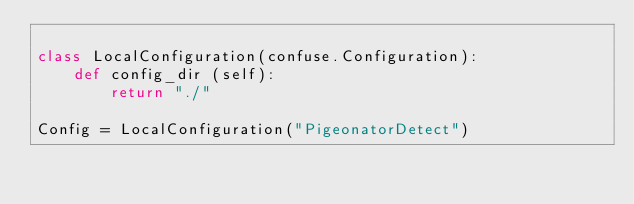<code> <loc_0><loc_0><loc_500><loc_500><_Python_>
class LocalConfiguration(confuse.Configuration):
    def config_dir (self):
        return "./"

Config = LocalConfiguration("PigeonatorDetect")</code> 